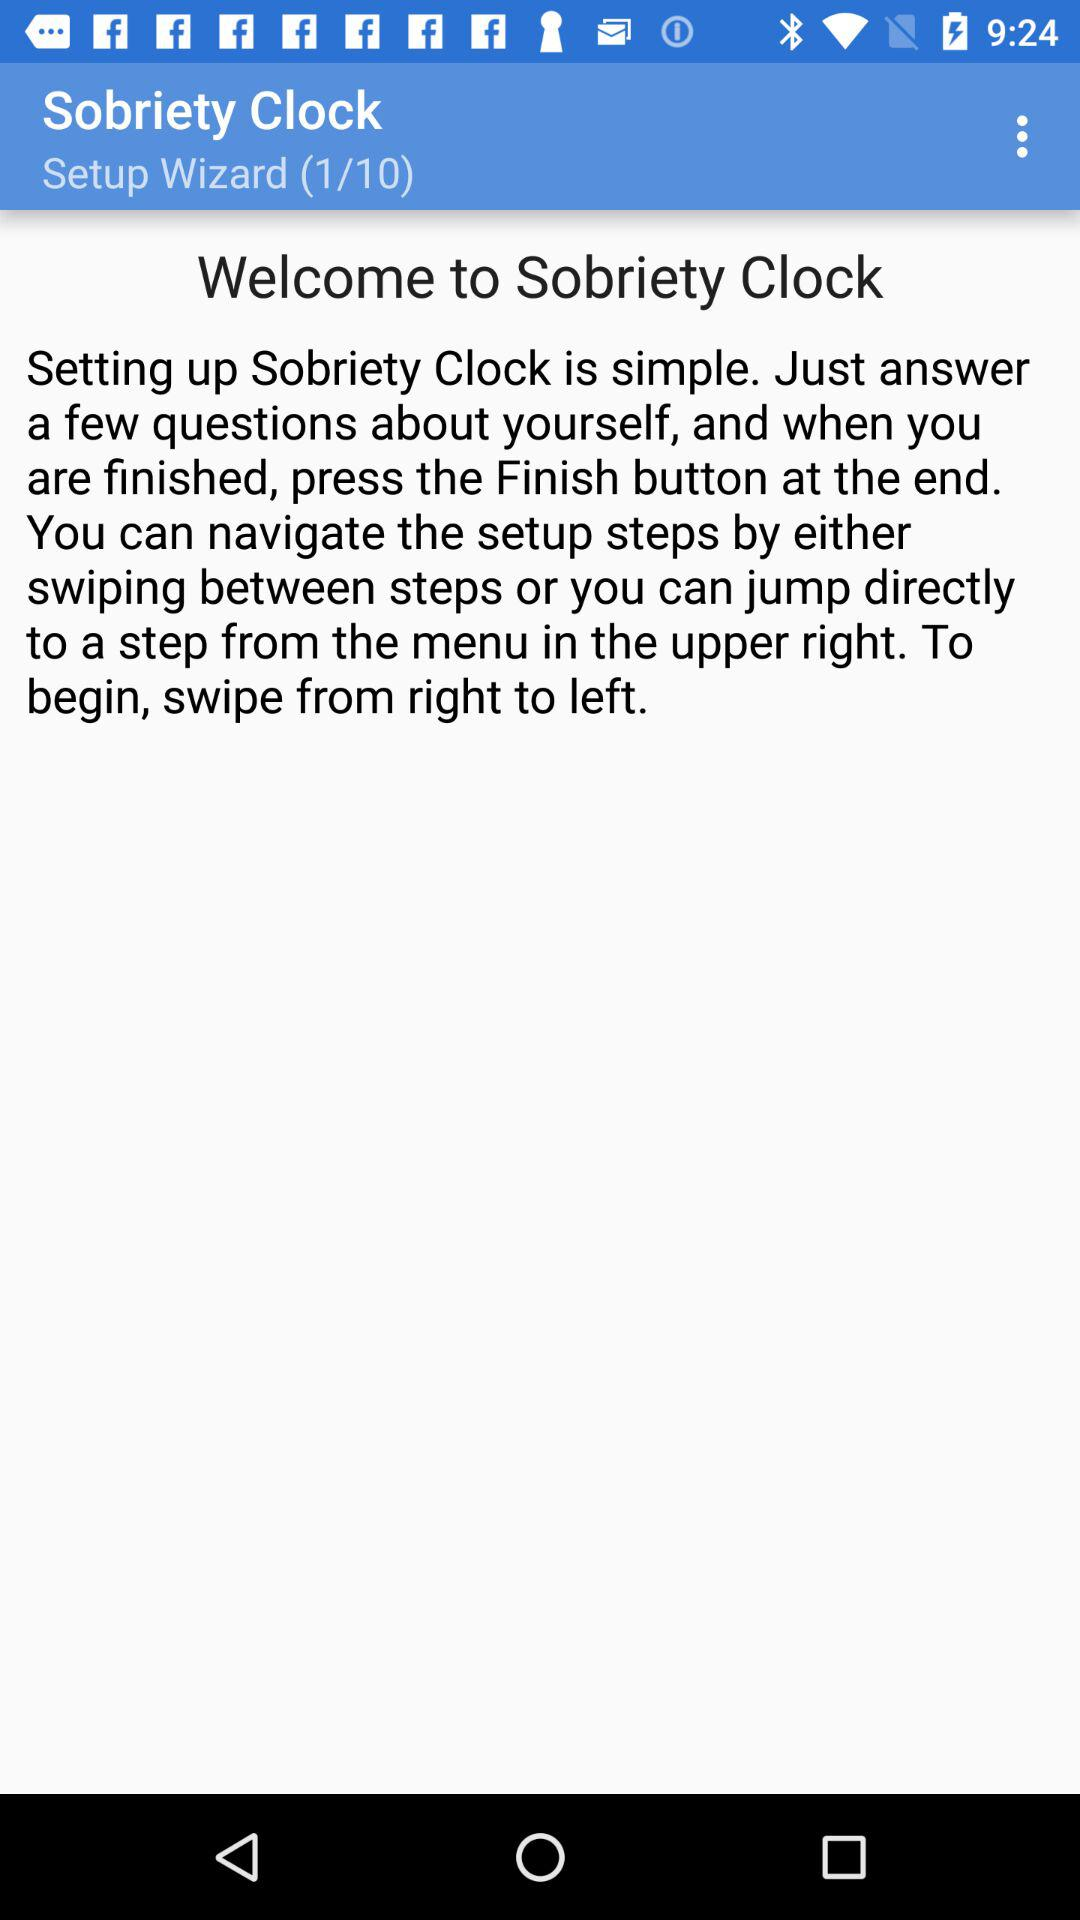How many total steps are there in the setup wizard? There are 10 steps. 